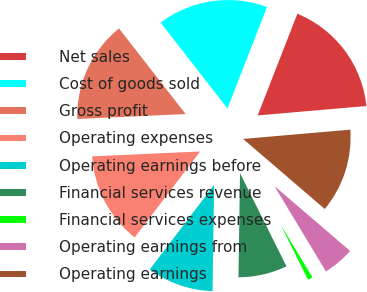<chart> <loc_0><loc_0><loc_500><loc_500><pie_chart><fcel>Net sales<fcel>Cost of goods sold<fcel>Gross profit<fcel>Operating expenses<fcel>Operating earnings before<fcel>Financial services revenue<fcel>Financial services expenses<fcel>Operating earnings from<fcel>Operating earnings<nl><fcel>17.71%<fcel>16.45%<fcel>15.19%<fcel>13.92%<fcel>10.13%<fcel>7.6%<fcel>1.28%<fcel>5.07%<fcel>12.66%<nl></chart> 